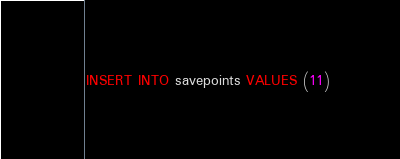<code> <loc_0><loc_0><loc_500><loc_500><_SQL_>INSERT INTO savepoints VALUES (11)
</code> 